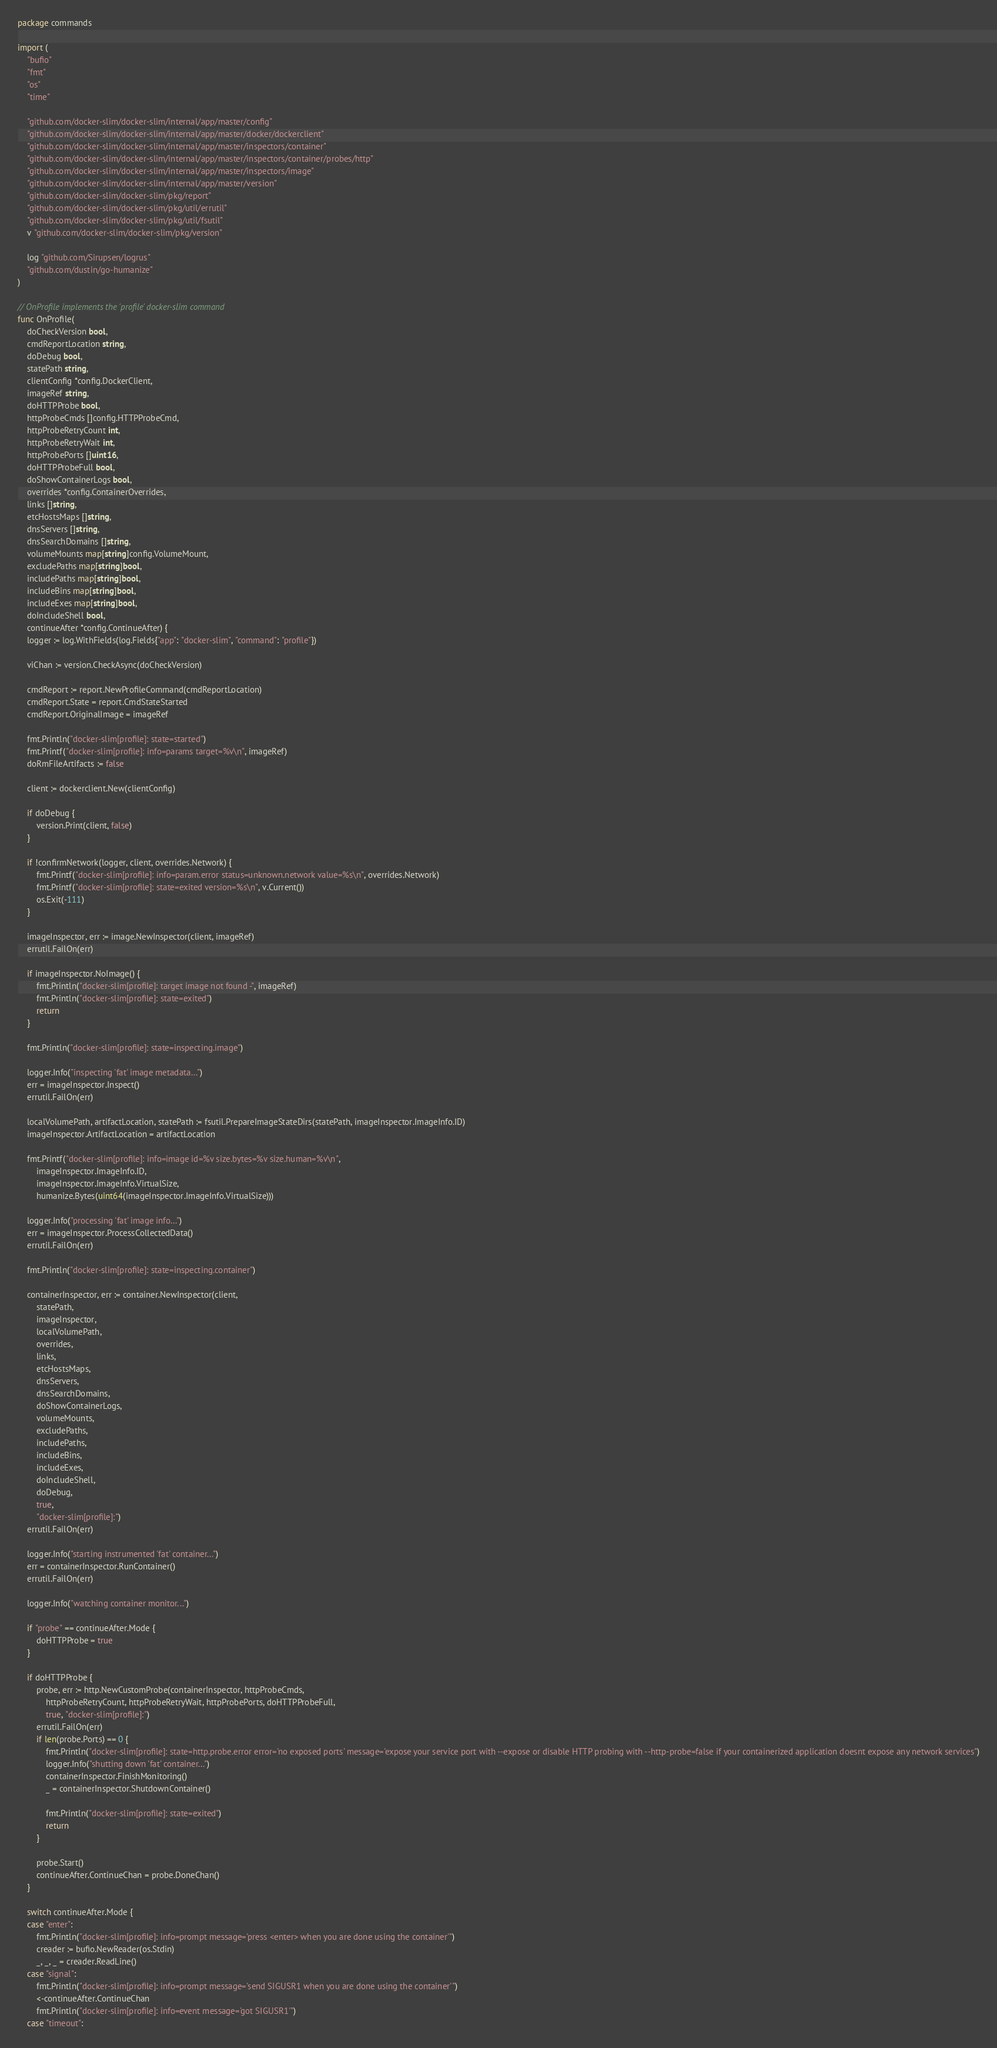<code> <loc_0><loc_0><loc_500><loc_500><_Go_>package commands

import (
	"bufio"
	"fmt"
	"os"
	"time"

	"github.com/docker-slim/docker-slim/internal/app/master/config"
	"github.com/docker-slim/docker-slim/internal/app/master/docker/dockerclient"
	"github.com/docker-slim/docker-slim/internal/app/master/inspectors/container"
	"github.com/docker-slim/docker-slim/internal/app/master/inspectors/container/probes/http"
	"github.com/docker-slim/docker-slim/internal/app/master/inspectors/image"
	"github.com/docker-slim/docker-slim/internal/app/master/version"
	"github.com/docker-slim/docker-slim/pkg/report"
	"github.com/docker-slim/docker-slim/pkg/util/errutil"
	"github.com/docker-slim/docker-slim/pkg/util/fsutil"
	v "github.com/docker-slim/docker-slim/pkg/version"

	log "github.com/Sirupsen/logrus"
	"github.com/dustin/go-humanize"
)

// OnProfile implements the 'profile' docker-slim command
func OnProfile(
	doCheckVersion bool,
	cmdReportLocation string,
	doDebug bool,
	statePath string,
	clientConfig *config.DockerClient,
	imageRef string,
	doHTTPProbe bool,
	httpProbeCmds []config.HTTPProbeCmd,
	httpProbeRetryCount int,
	httpProbeRetryWait int,
	httpProbePorts []uint16,
	doHTTPProbeFull bool,
	doShowContainerLogs bool,
	overrides *config.ContainerOverrides,
	links []string,
	etcHostsMaps []string,
	dnsServers []string,
	dnsSearchDomains []string,
	volumeMounts map[string]config.VolumeMount,
	excludePaths map[string]bool,
	includePaths map[string]bool,
	includeBins map[string]bool,
	includeExes map[string]bool,
	doIncludeShell bool,
	continueAfter *config.ContinueAfter) {
	logger := log.WithFields(log.Fields{"app": "docker-slim", "command": "profile"})

	viChan := version.CheckAsync(doCheckVersion)

	cmdReport := report.NewProfileCommand(cmdReportLocation)
	cmdReport.State = report.CmdStateStarted
	cmdReport.OriginalImage = imageRef

	fmt.Println("docker-slim[profile]: state=started")
	fmt.Printf("docker-slim[profile]: info=params target=%v\n", imageRef)
	doRmFileArtifacts := false

	client := dockerclient.New(clientConfig)

	if doDebug {
		version.Print(client, false)
	}

	if !confirmNetwork(logger, client, overrides.Network) {
		fmt.Printf("docker-slim[profile]: info=param.error status=unknown.network value=%s\n", overrides.Network)
		fmt.Printf("docker-slim[profile]: state=exited version=%s\n", v.Current())
		os.Exit(-111)
	}

	imageInspector, err := image.NewInspector(client, imageRef)
	errutil.FailOn(err)

	if imageInspector.NoImage() {
		fmt.Println("docker-slim[profile]: target image not found -", imageRef)
		fmt.Println("docker-slim[profile]: state=exited")
		return
	}

	fmt.Println("docker-slim[profile]: state=inspecting.image")

	logger.Info("inspecting 'fat' image metadata...")
	err = imageInspector.Inspect()
	errutil.FailOn(err)

	localVolumePath, artifactLocation, statePath := fsutil.PrepareImageStateDirs(statePath, imageInspector.ImageInfo.ID)
	imageInspector.ArtifactLocation = artifactLocation

	fmt.Printf("docker-slim[profile]: info=image id=%v size.bytes=%v size.human=%v\n",
		imageInspector.ImageInfo.ID,
		imageInspector.ImageInfo.VirtualSize,
		humanize.Bytes(uint64(imageInspector.ImageInfo.VirtualSize)))

	logger.Info("processing 'fat' image info...")
	err = imageInspector.ProcessCollectedData()
	errutil.FailOn(err)

	fmt.Println("docker-slim[profile]: state=inspecting.container")

	containerInspector, err := container.NewInspector(client,
		statePath,
		imageInspector,
		localVolumePath,
		overrides,
		links,
		etcHostsMaps,
		dnsServers,
		dnsSearchDomains,
		doShowContainerLogs,
		volumeMounts,
		excludePaths,
		includePaths,
		includeBins,
		includeExes,
		doIncludeShell,
		doDebug,
		true,
		"docker-slim[profile]:")
	errutil.FailOn(err)

	logger.Info("starting instrumented 'fat' container...")
	err = containerInspector.RunContainer()
	errutil.FailOn(err)

	logger.Info("watching container monitor...")

	if "probe" == continueAfter.Mode {
		doHTTPProbe = true
	}

	if doHTTPProbe {
		probe, err := http.NewCustomProbe(containerInspector, httpProbeCmds,
			httpProbeRetryCount, httpProbeRetryWait, httpProbePorts, doHTTPProbeFull,
			true, "docker-slim[profile]:")
		errutil.FailOn(err)
		if len(probe.Ports) == 0 {
			fmt.Println("docker-slim[profile]: state=http.probe.error error='no exposed ports' message='expose your service port with --expose or disable HTTP probing with --http-probe=false if your containerized application doesnt expose any network services")
			logger.Info("shutting down 'fat' container...")
			containerInspector.FinishMonitoring()
			_ = containerInspector.ShutdownContainer()

			fmt.Println("docker-slim[profile]: state=exited")
			return
		}

		probe.Start()
		continueAfter.ContinueChan = probe.DoneChan()
	}

	switch continueAfter.Mode {
	case "enter":
		fmt.Println("docker-slim[profile]: info=prompt message='press <enter> when you are done using the container'")
		creader := bufio.NewReader(os.Stdin)
		_, _, _ = creader.ReadLine()
	case "signal":
		fmt.Println("docker-slim[profile]: info=prompt message='send SIGUSR1 when you are done using the container'")
		<-continueAfter.ContinueChan
		fmt.Println("docker-slim[profile]: info=event message='got SIGUSR1'")
	case "timeout":</code> 